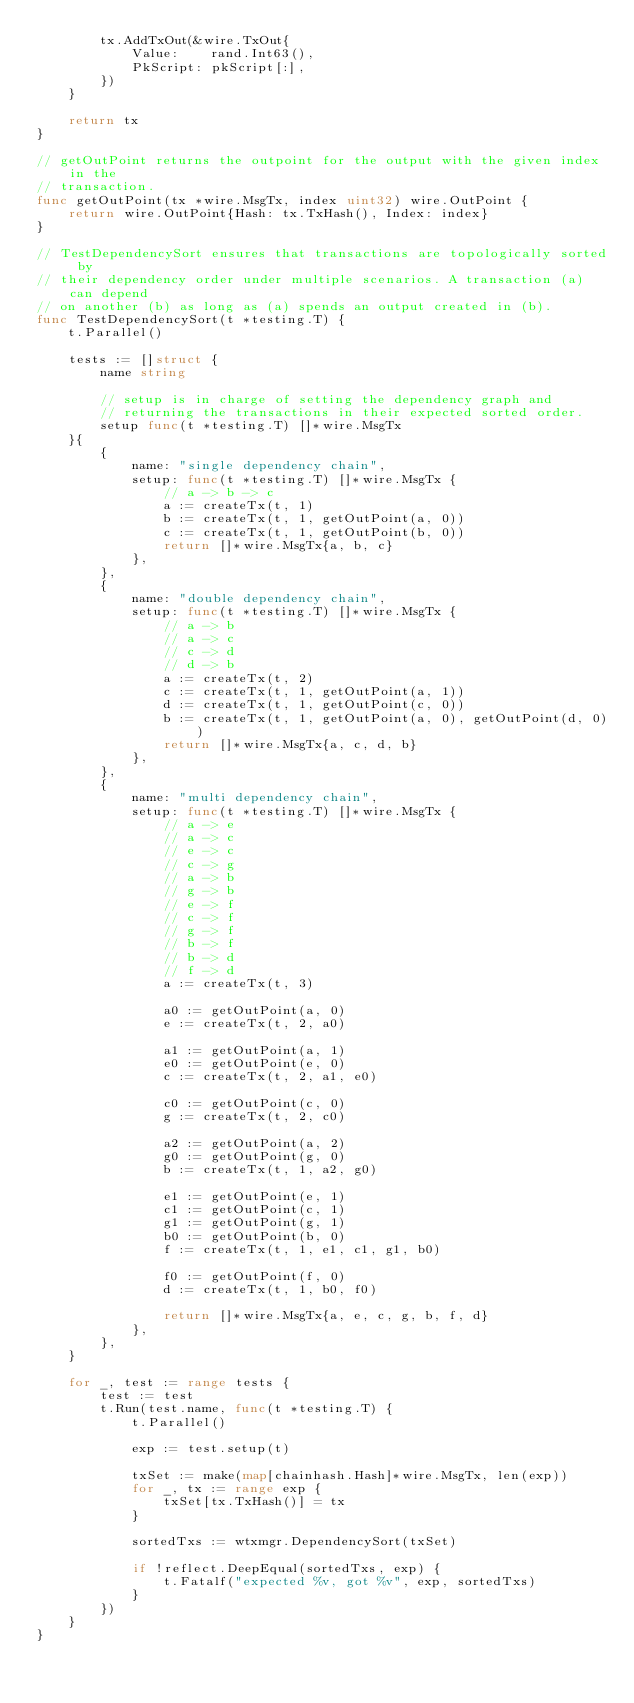<code> <loc_0><loc_0><loc_500><loc_500><_Go_>		tx.AddTxOut(&wire.TxOut{
			Value:    rand.Int63(),
			PkScript: pkScript[:],
		})
	}

	return tx
}

// getOutPoint returns the outpoint for the output with the given index in the
// transaction.
func getOutPoint(tx *wire.MsgTx, index uint32) wire.OutPoint {
	return wire.OutPoint{Hash: tx.TxHash(), Index: index}
}

// TestDependencySort ensures that transactions are topologically sorted by
// their dependency order under multiple scenarios. A transaction (a) can depend
// on another (b) as long as (a) spends an output created in (b).
func TestDependencySort(t *testing.T) {
	t.Parallel()

	tests := []struct {
		name string

		// setup is in charge of setting the dependency graph and
		// returning the transactions in their expected sorted order.
		setup func(t *testing.T) []*wire.MsgTx
	}{
		{
			name: "single dependency chain",
			setup: func(t *testing.T) []*wire.MsgTx {
				// a -> b -> c
				a := createTx(t, 1)
				b := createTx(t, 1, getOutPoint(a, 0))
				c := createTx(t, 1, getOutPoint(b, 0))
				return []*wire.MsgTx{a, b, c}
			},
		},
		{
			name: "double dependency chain",
			setup: func(t *testing.T) []*wire.MsgTx {
				// a -> b
				// a -> c
				// c -> d
				// d -> b
				a := createTx(t, 2)
				c := createTx(t, 1, getOutPoint(a, 1))
				d := createTx(t, 1, getOutPoint(c, 0))
				b := createTx(t, 1, getOutPoint(a, 0), getOutPoint(d, 0))
				return []*wire.MsgTx{a, c, d, b}
			},
		},
		{
			name: "multi dependency chain",
			setup: func(t *testing.T) []*wire.MsgTx {
				// a -> e
				// a -> c
				// e -> c
				// c -> g
				// a -> b
				// g -> b
				// e -> f
				// c -> f
				// g -> f
				// b -> f
				// b -> d
				// f -> d
				a := createTx(t, 3)

				a0 := getOutPoint(a, 0)
				e := createTx(t, 2, a0)

				a1 := getOutPoint(a, 1)
				e0 := getOutPoint(e, 0)
				c := createTx(t, 2, a1, e0)

				c0 := getOutPoint(c, 0)
				g := createTx(t, 2, c0)

				a2 := getOutPoint(a, 2)
				g0 := getOutPoint(g, 0)
				b := createTx(t, 1, a2, g0)

				e1 := getOutPoint(e, 1)
				c1 := getOutPoint(c, 1)
				g1 := getOutPoint(g, 1)
				b0 := getOutPoint(b, 0)
				f := createTx(t, 1, e1, c1, g1, b0)

				f0 := getOutPoint(f, 0)
				d := createTx(t, 1, b0, f0)

				return []*wire.MsgTx{a, e, c, g, b, f, d}
			},
		},
	}

	for _, test := range tests {
		test := test
		t.Run(test.name, func(t *testing.T) {
			t.Parallel()

			exp := test.setup(t)

			txSet := make(map[chainhash.Hash]*wire.MsgTx, len(exp))
			for _, tx := range exp {
				txSet[tx.TxHash()] = tx
			}

			sortedTxs := wtxmgr.DependencySort(txSet)

			if !reflect.DeepEqual(sortedTxs, exp) {
				t.Fatalf("expected %v, got %v", exp, sortedTxs)
			}
		})
	}
}
</code> 